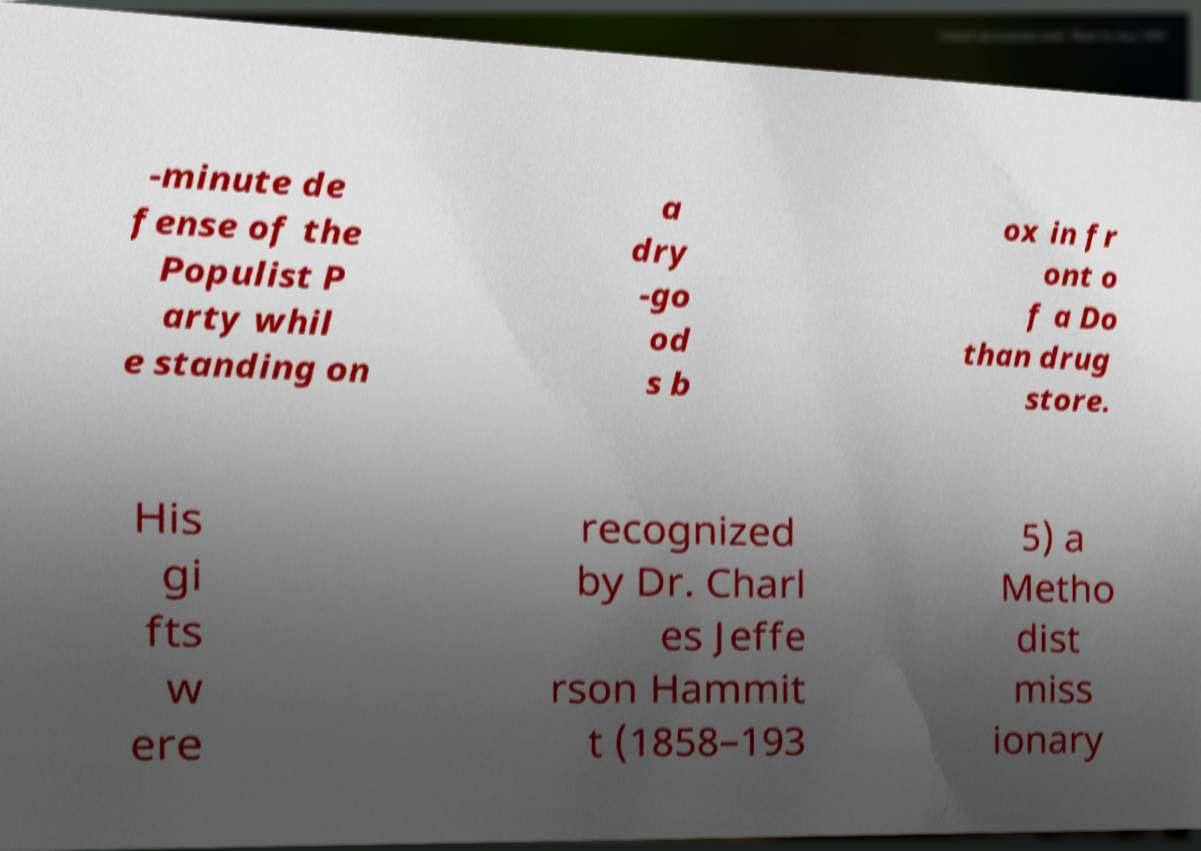Could you extract and type out the text from this image? -minute de fense of the Populist P arty whil e standing on a dry -go od s b ox in fr ont o f a Do than drug store. His gi fts w ere recognized by Dr. Charl es Jeffe rson Hammit t (1858–193 5) a Metho dist miss ionary 